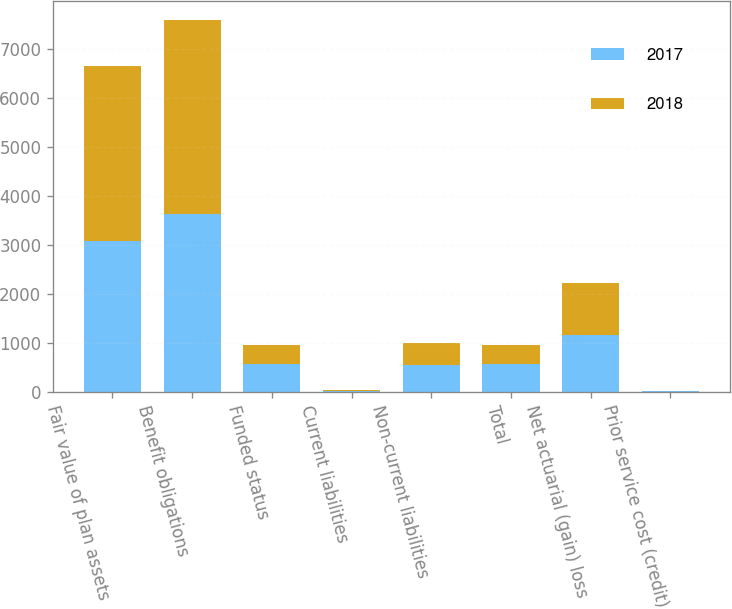Convert chart to OTSL. <chart><loc_0><loc_0><loc_500><loc_500><stacked_bar_chart><ecel><fcel>Fair value of plan assets<fcel>Benefit obligations<fcel>Funded status<fcel>Current liabilities<fcel>Non-current liabilities<fcel>Total<fcel>Net actuarial (gain) loss<fcel>Prior service cost (credit)<nl><fcel>2017<fcel>3068<fcel>3633<fcel>565<fcel>20<fcel>545<fcel>565<fcel>1153<fcel>7<nl><fcel>2018<fcel>3585<fcel>3961<fcel>376<fcel>15<fcel>443<fcel>376<fcel>1059<fcel>4<nl></chart> 